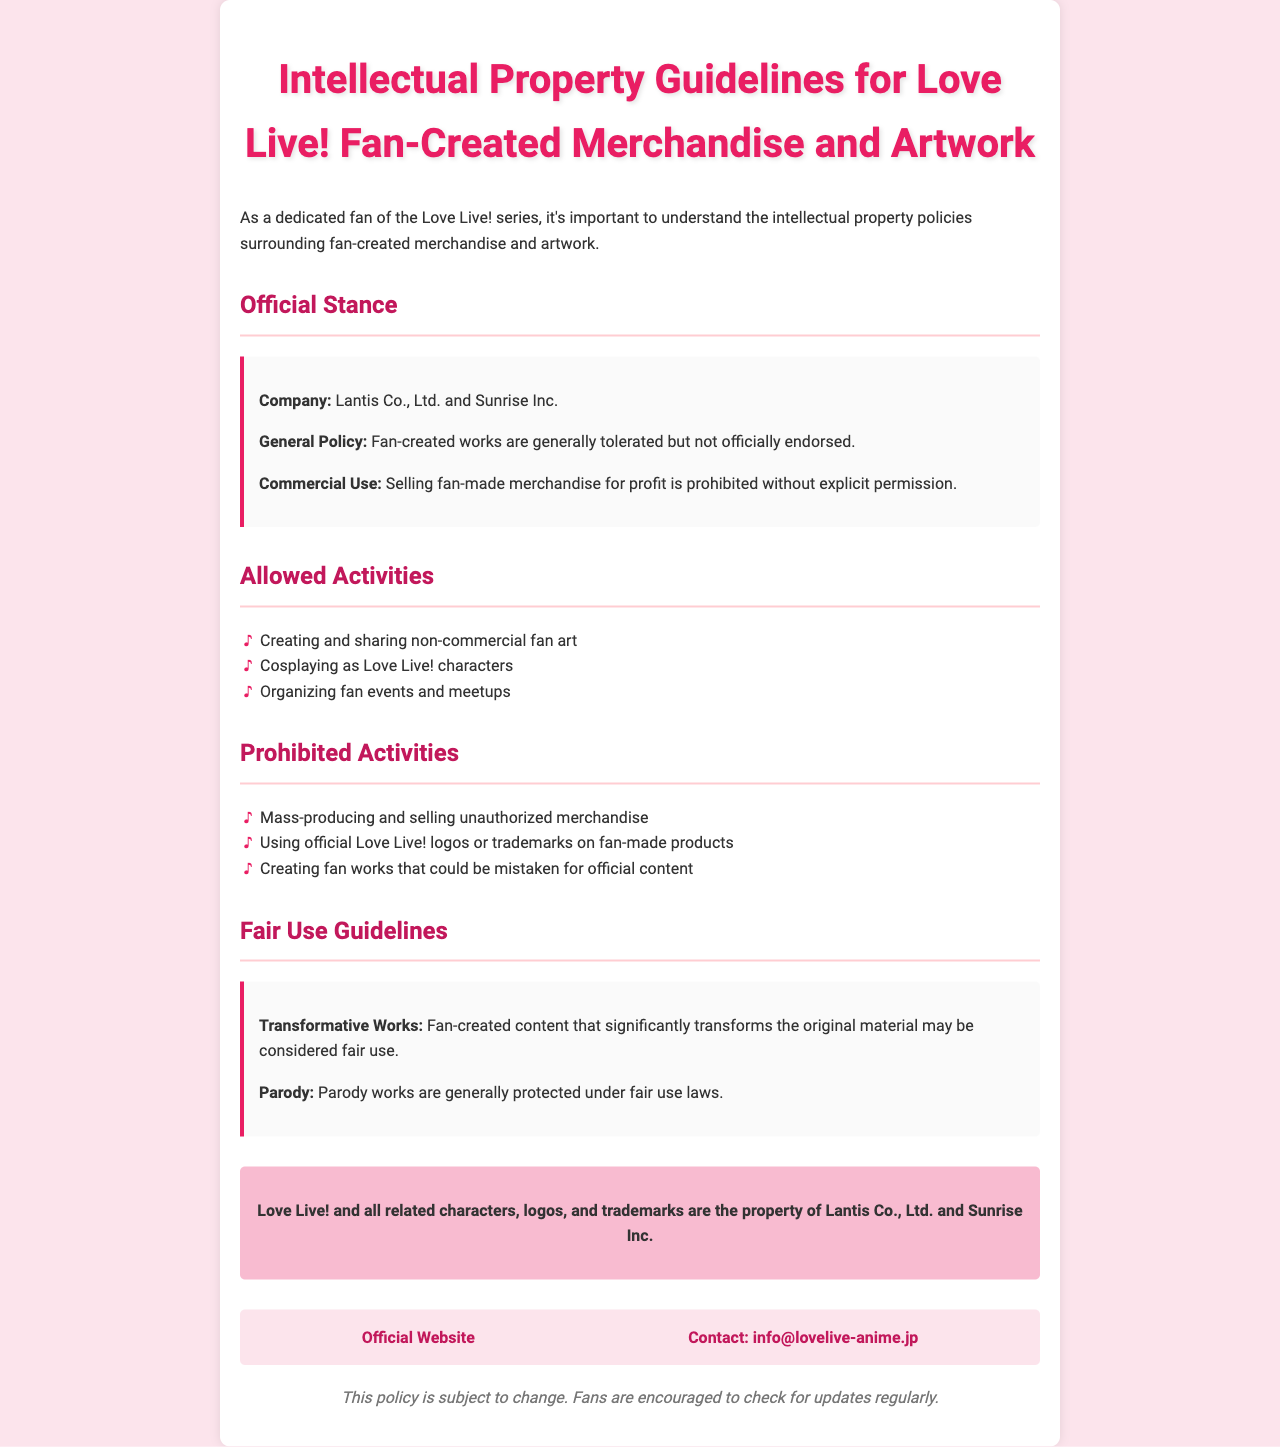what is the name of the companies involved in the Love Live! intellectual property policy? The document states the companies involved are Lantis Co., Ltd. and Sunrise Inc.
Answer: Lantis Co., Ltd. and Sunrise Inc is selling fan-made merchandise for profit allowed? The general policy indicates that selling fan-made merchandise for profit is prohibited without explicit permission.
Answer: No which activities are allowed according to the policy? The document lists allowed activities such as creating non-commercial fan art, cosplaying, and organizing fan events.
Answer: Creating non-commercial fan art what type of works are considered fair use? The policy states that transformative works and parody works may be considered fair use.
Answer: Transformative works what should fans do to stay updated on policy changes? The document advises fans to check for updates regularly since the policy is subject to change.
Answer: Check for updates regularly what color is used for the main heading in the document? The heading color is specified in the CSS as #e91e63, which is a shade of pink.
Answer: #e91e63 how are prohibited activities described in the document? The prohibited activities are listed clearly under a dedicated section with bullet points for easy reading.
Answer: Listed clearly under a dedicated section what is the email contact provided in the document? The document provides an email contact for inquiries, specifically info@lovelive-anime.jp.
Answer: info@lovelive-anime.jp 